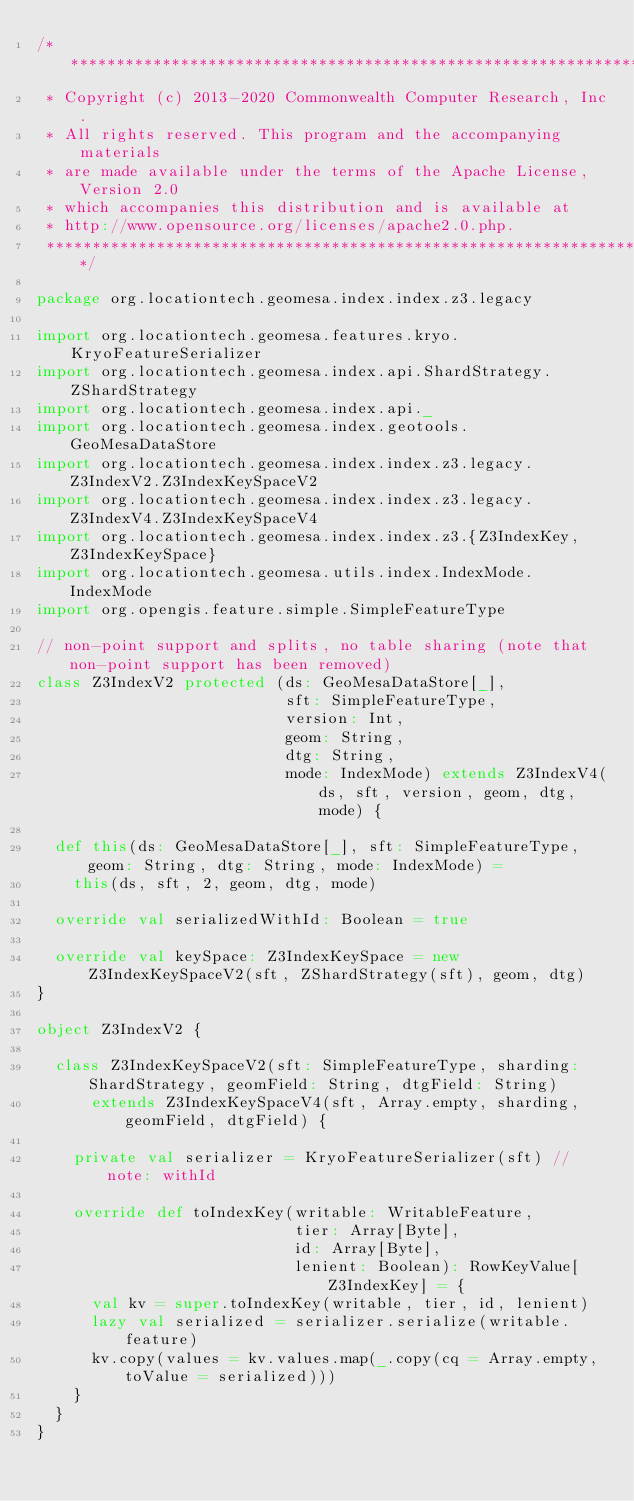Convert code to text. <code><loc_0><loc_0><loc_500><loc_500><_Scala_>/***********************************************************************
 * Copyright (c) 2013-2020 Commonwealth Computer Research, Inc.
 * All rights reserved. This program and the accompanying materials
 * are made available under the terms of the Apache License, Version 2.0
 * which accompanies this distribution and is available at
 * http://www.opensource.org/licenses/apache2.0.php.
 ***********************************************************************/

package org.locationtech.geomesa.index.index.z3.legacy

import org.locationtech.geomesa.features.kryo.KryoFeatureSerializer
import org.locationtech.geomesa.index.api.ShardStrategy.ZShardStrategy
import org.locationtech.geomesa.index.api._
import org.locationtech.geomesa.index.geotools.GeoMesaDataStore
import org.locationtech.geomesa.index.index.z3.legacy.Z3IndexV2.Z3IndexKeySpaceV2
import org.locationtech.geomesa.index.index.z3.legacy.Z3IndexV4.Z3IndexKeySpaceV4
import org.locationtech.geomesa.index.index.z3.{Z3IndexKey, Z3IndexKeySpace}
import org.locationtech.geomesa.utils.index.IndexMode.IndexMode
import org.opengis.feature.simple.SimpleFeatureType

// non-point support and splits, no table sharing (note that non-point support has been removed)
class Z3IndexV2 protected (ds: GeoMesaDataStore[_],
                           sft: SimpleFeatureType,
                           version: Int,
                           geom: String,
                           dtg: String,
                           mode: IndexMode) extends Z3IndexV4(ds, sft, version, geom, dtg, mode) {

  def this(ds: GeoMesaDataStore[_], sft: SimpleFeatureType, geom: String, dtg: String, mode: IndexMode) =
    this(ds, sft, 2, geom, dtg, mode)

  override val serializedWithId: Boolean = true

  override val keySpace: Z3IndexKeySpace = new Z3IndexKeySpaceV2(sft, ZShardStrategy(sft), geom, dtg)
}

object Z3IndexV2 {

  class Z3IndexKeySpaceV2(sft: SimpleFeatureType, sharding: ShardStrategy, geomField: String, dtgField: String)
      extends Z3IndexKeySpaceV4(sft, Array.empty, sharding, geomField, dtgField) {

    private val serializer = KryoFeatureSerializer(sft) // note: withId

    override def toIndexKey(writable: WritableFeature,
                            tier: Array[Byte],
                            id: Array[Byte],
                            lenient: Boolean): RowKeyValue[Z3IndexKey] = {
      val kv = super.toIndexKey(writable, tier, id, lenient)
      lazy val serialized = serializer.serialize(writable.feature)
      kv.copy(values = kv.values.map(_.copy(cq = Array.empty, toValue = serialized)))
    }
  }
}
</code> 